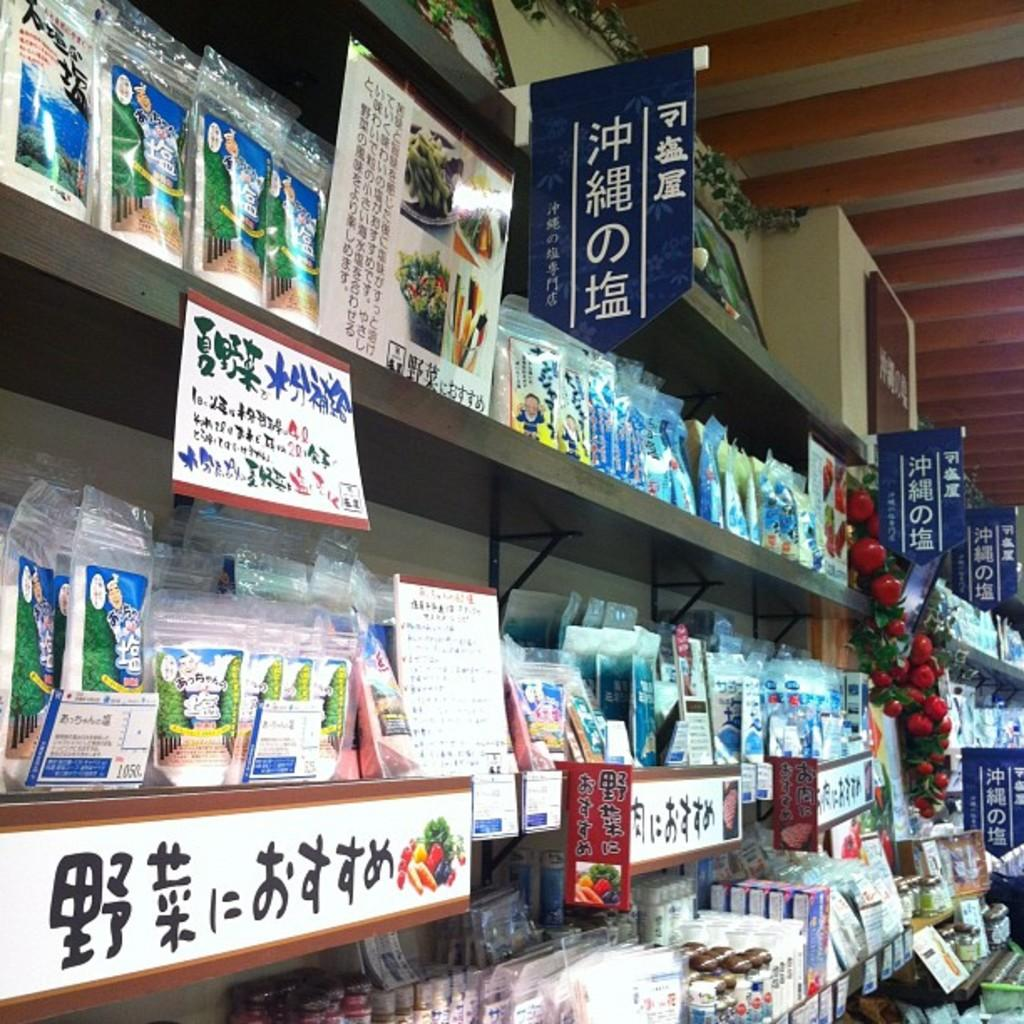<image>
Write a terse but informative summary of the picture. Shelves of Asian products and periodicals include one label with the number 1050 on it. 